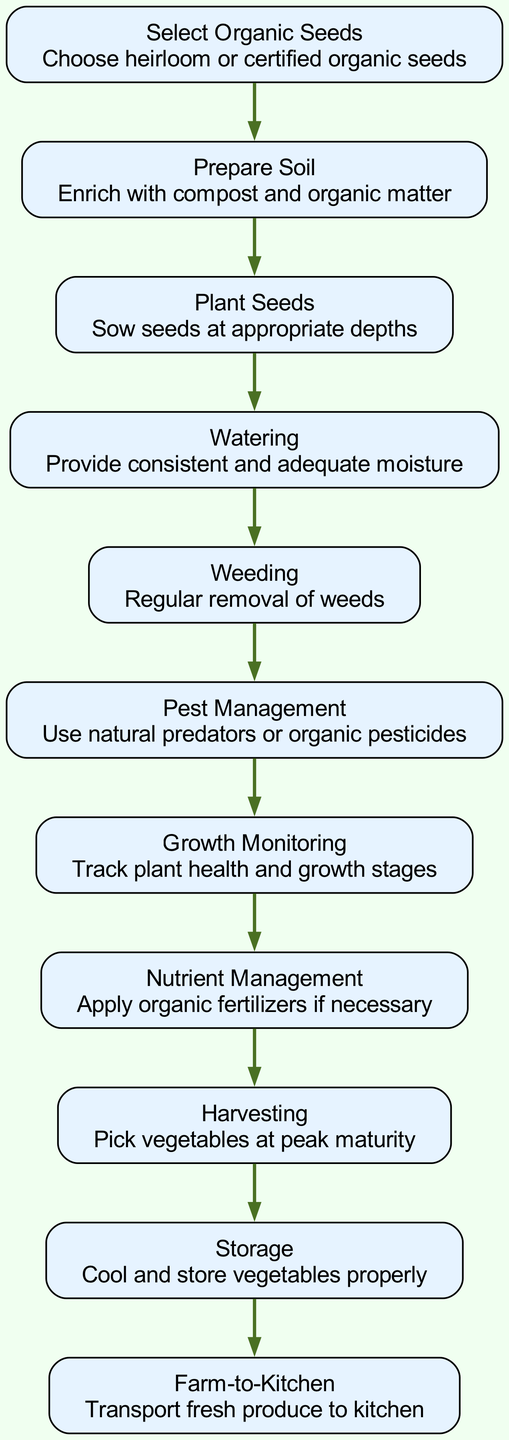What is the first step in the diagram? The first step in the diagram is represented by the first node, which indicates to "Select Organic Seeds." This step is crucial to start the lifecycle of organic vegetables.
Answer: Select Organic Seeds How many total nodes are there in the diagram? By counting the number of distinct steps represented, we find there are 11 nodes in total that outline the lifecycle from planting to harvest.
Answer: 11 What follows "Weeding" in the diagram? The node that comes directly after "Weeding" is "Pest Management," establishing a sequence in the lifecycle where pest issues are addressed following weed control.
Answer: Pest Management What is the purpose of the "Storage" step? The "Storage" step is crucial for maintaining the quality of harvested vegetables, as it involves cooling and storing them properly to prevent spoilage before they reach the kitchen.
Answer: Cool and store vegetables properly Which step immediately precedes "Harvesting"? The step right before "Harvesting" is "Nutrient Management," indicating that nutrient-related tasks are handled prior to the harvesting of the vegetables, ensuring they are well-fed for peak maturity.
Answer: Nutrient Management How are the vegetables transported to the kitchen? The diagram indicates that vegetables are transported to the kitchen through the "Farm-to-Kitchen" step, which signifies the delivery of fresh produce after harvesting.
Answer: Transport fresh produce to kitchen What is the relationship between "Prepare Soil" and "Plant Seeds"? "Prepare Soil" is the first step, and "Plant Seeds" follows directly afterward, indicating that soil preparation must occur before seeds can be planted effectively.
Answer: Prepare Soil -> Plant Seeds What type of seeds should be selected? The diagram specifies the selection of either heirloom or certified organic seeds, emphasizing the importance of quality in starting the vegetable lifecycle.
Answer: Heirloom or certified organic seeds What does the "Growth Monitoring" step involve? "Growth Monitoring" involves tracking plant health and growth stages, which is essential to ensure that the plants are developing correctly throughout their lifecycle.
Answer: Track plant health and growth stages 